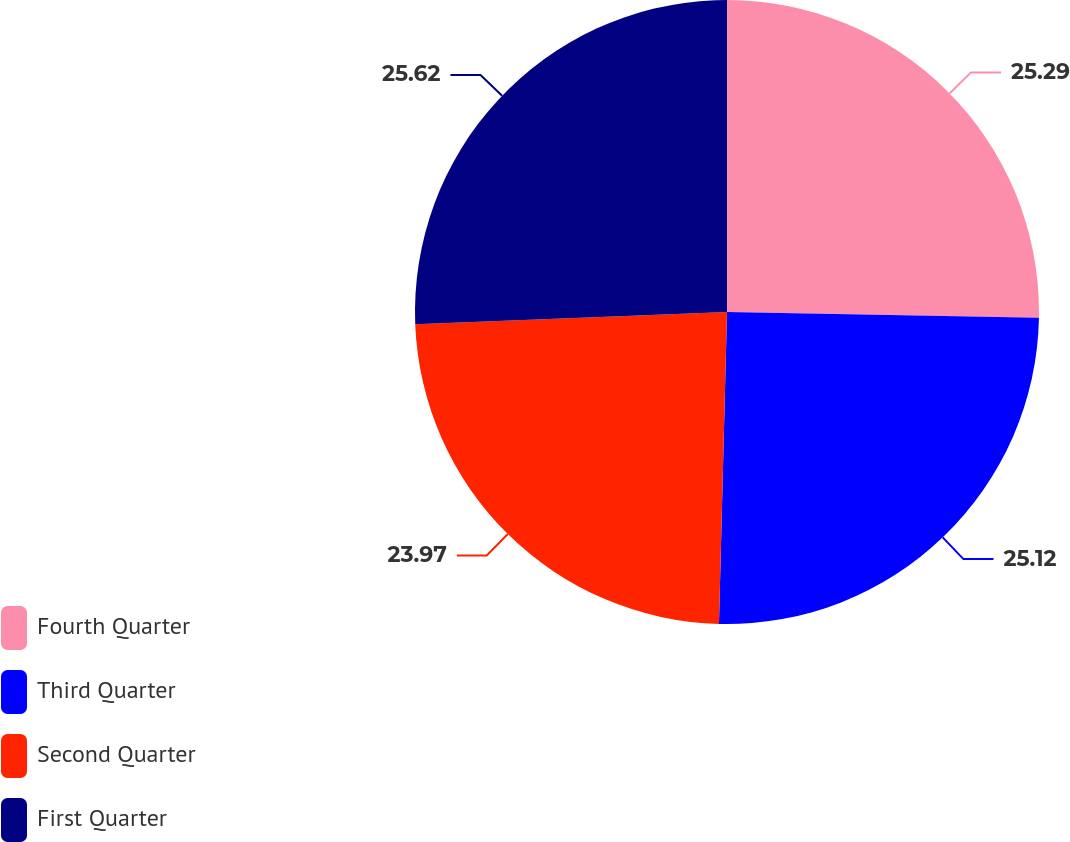<chart> <loc_0><loc_0><loc_500><loc_500><pie_chart><fcel>Fourth Quarter<fcel>Third Quarter<fcel>Second Quarter<fcel>First Quarter<nl><fcel>25.29%<fcel>25.12%<fcel>23.97%<fcel>25.62%<nl></chart> 